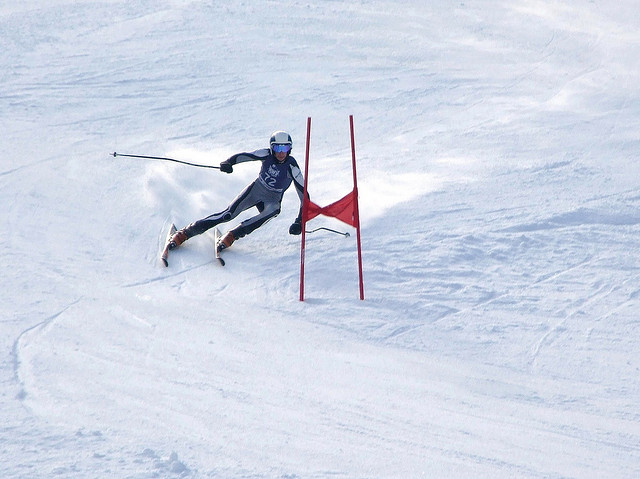Read all the text in this image. 72 